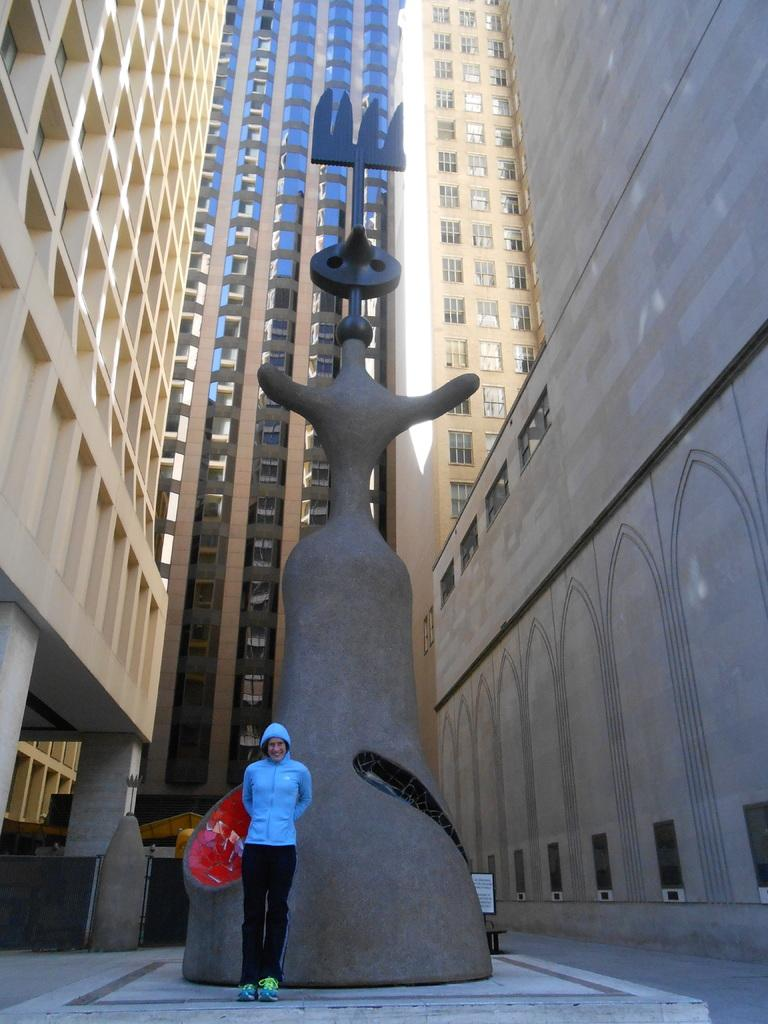Who or what is in the image? There is a person in the image. What is the person doing in the image? The person is standing in front of a statue. What else can be seen in the image besides the person and the statue? There are buildings visible in the image. What type of magic is being performed by the person in the image? There is no indication of magic or any magical activity in the image. 